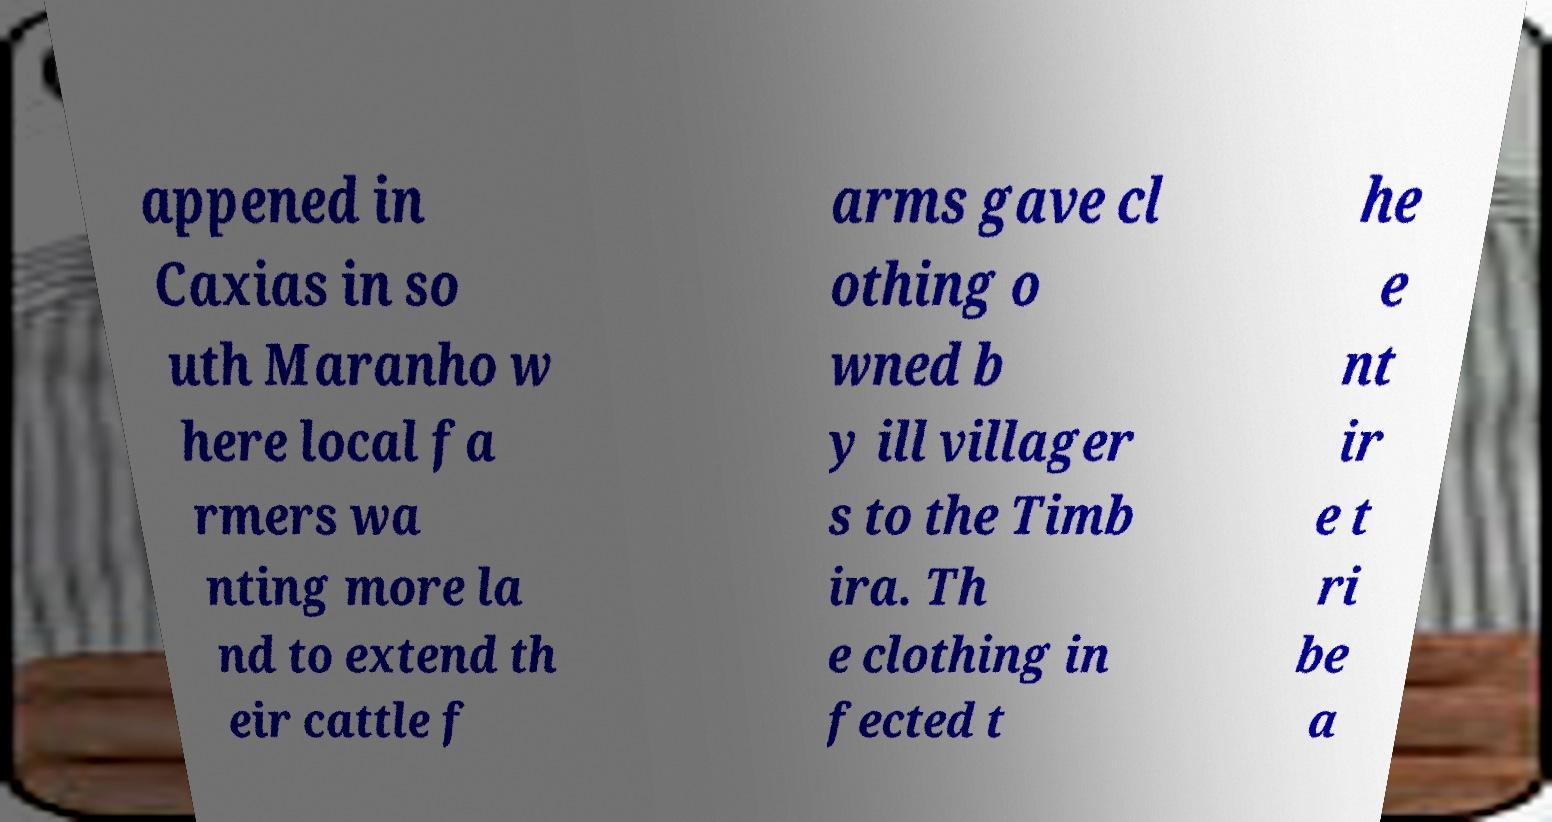Please read and relay the text visible in this image. What does it say? appened in Caxias in so uth Maranho w here local fa rmers wa nting more la nd to extend th eir cattle f arms gave cl othing o wned b y ill villager s to the Timb ira. Th e clothing in fected t he e nt ir e t ri be a 